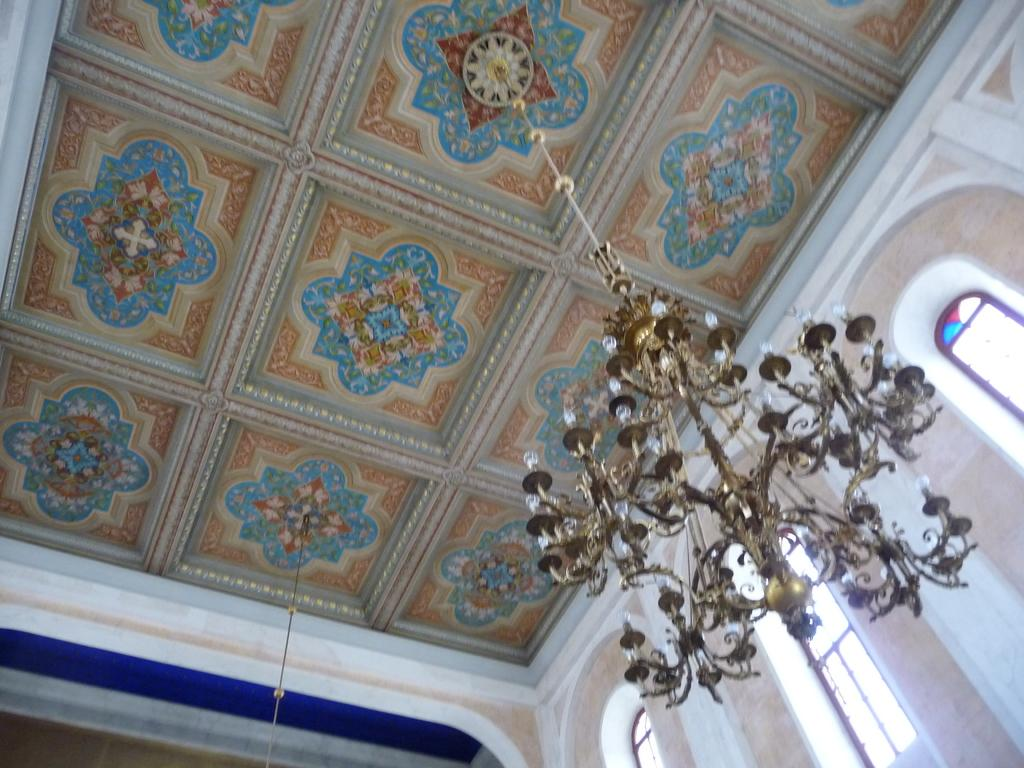What type of location is depicted in the image? The image is an inside view of a room. Where are the windows located in the room? The windows are on the right side of the room. What type of lighting fixture is present in the room? There is a chandelier hanging from the top of the room. What type of hobbies are being practiced in the room? There is no indication of any hobbies being practiced in the image, as it only shows an inside view of a room with a chandelier and windows. 